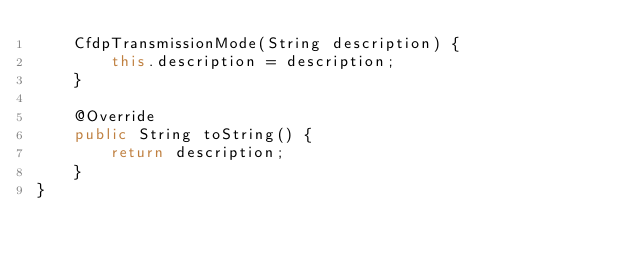Convert code to text. <code><loc_0><loc_0><loc_500><loc_500><_Java_>    CfdpTransmissionMode(String description) {
        this.description = description;
    }

    @Override
    public String toString() {
        return description;
    }
}
</code> 